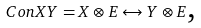<formula> <loc_0><loc_0><loc_500><loc_500>C o n X Y = X \otimes E \leftrightarrow Y \otimes E \text  ,</formula> 